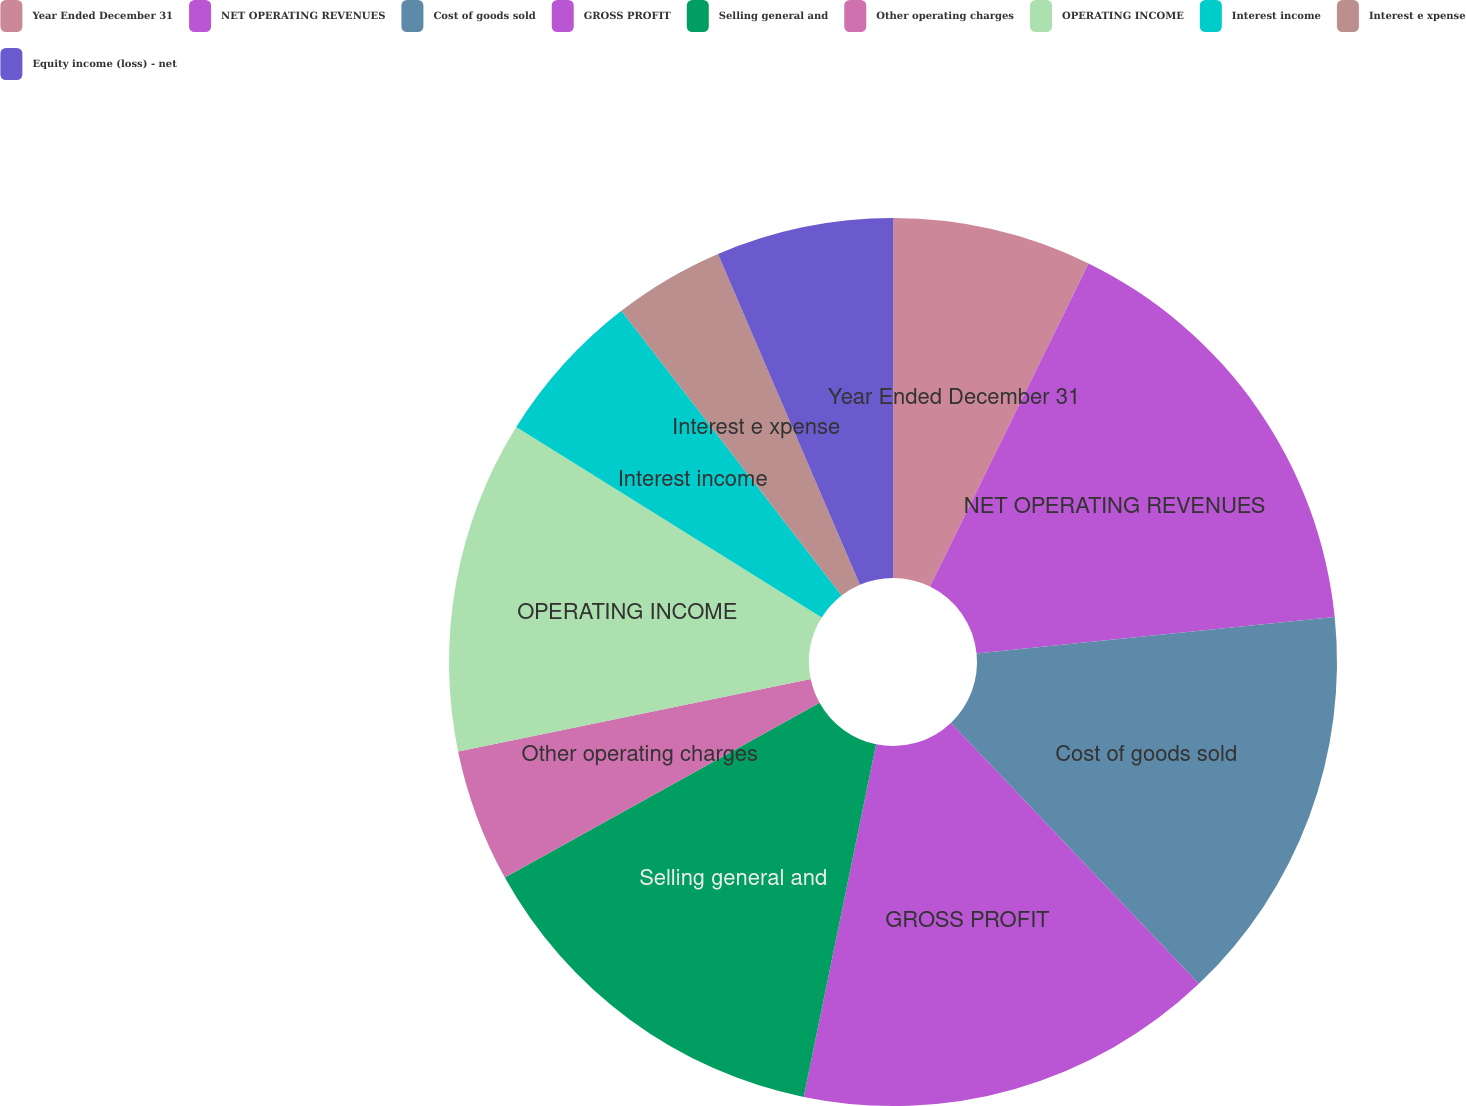<chart> <loc_0><loc_0><loc_500><loc_500><pie_chart><fcel>Year Ended December 31<fcel>NET OPERATING REVENUES<fcel>Cost of goods sold<fcel>GROSS PROFIT<fcel>Selling general and<fcel>Other operating charges<fcel>OPERATING INCOME<fcel>Interest income<fcel>Interest e xpense<fcel>Equity income (loss) - net<nl><fcel>7.26%<fcel>16.13%<fcel>14.52%<fcel>15.32%<fcel>13.71%<fcel>4.84%<fcel>12.1%<fcel>5.65%<fcel>4.03%<fcel>6.45%<nl></chart> 